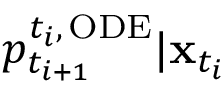<formula> <loc_0><loc_0><loc_500><loc_500>p _ { t _ { i + 1 } } ^ { { t _ { i } } , \, O D E } | x _ { t _ { i } }</formula> 